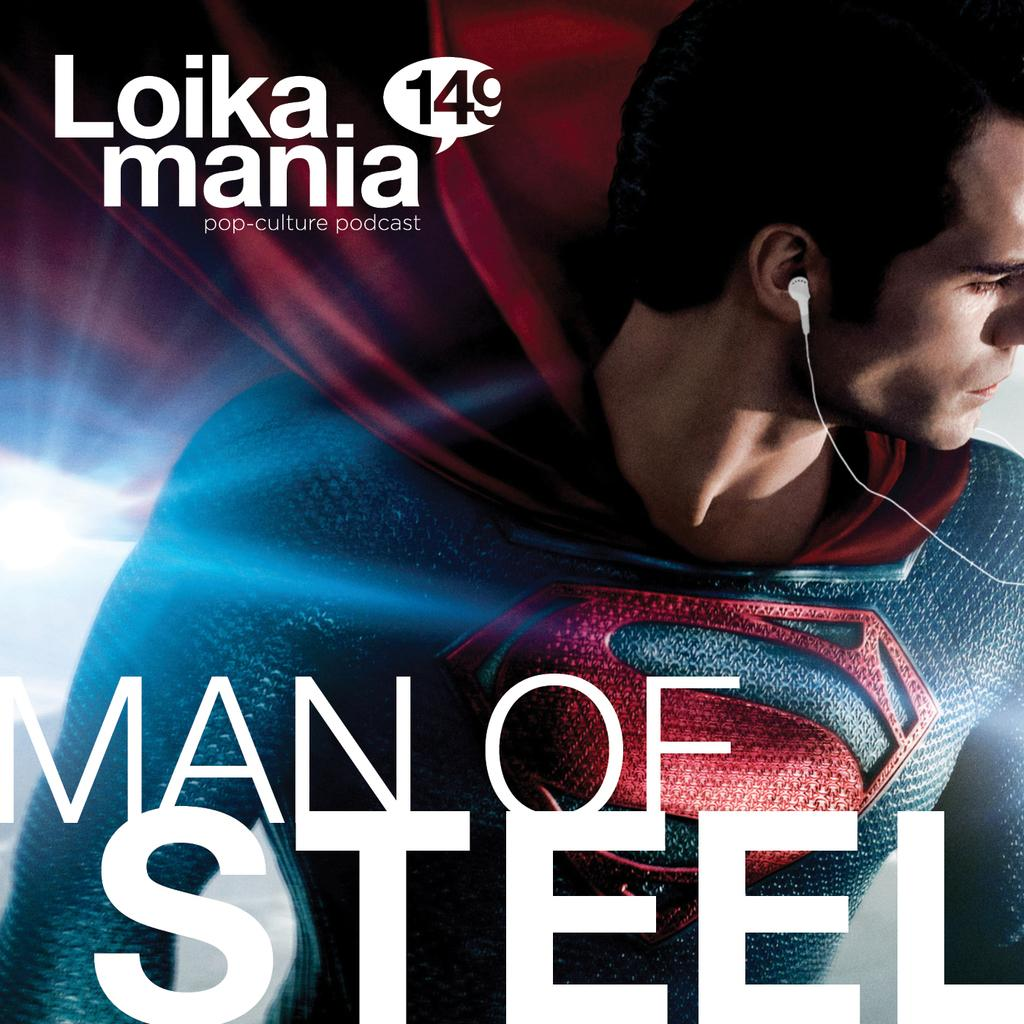What type of image is being described? The image is a poster. What can be found at the bottom of the poster? There is text at the bottom of the poster. Who or what is the main subject of the poster? There is a man in the middle of the poster. What type of breakfast is the man eating in the image? There is no breakfast present in the image, as it is a poster featuring a man in the middle. 